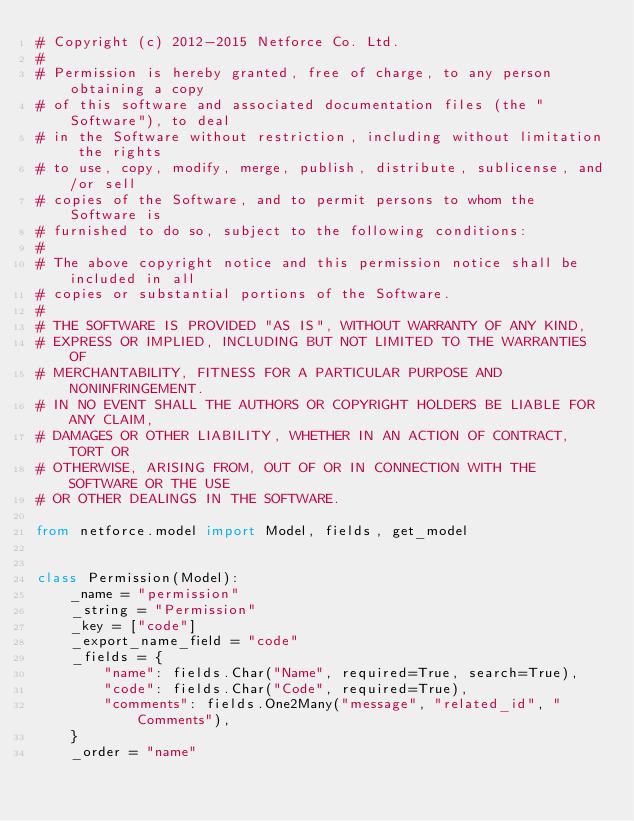Convert code to text. <code><loc_0><loc_0><loc_500><loc_500><_Python_># Copyright (c) 2012-2015 Netforce Co. Ltd.
# 
# Permission is hereby granted, free of charge, to any person obtaining a copy
# of this software and associated documentation files (the "Software"), to deal
# in the Software without restriction, including without limitation the rights
# to use, copy, modify, merge, publish, distribute, sublicense, and/or sell
# copies of the Software, and to permit persons to whom the Software is
# furnished to do so, subject to the following conditions:
# 
# The above copyright notice and this permission notice shall be included in all
# copies or substantial portions of the Software.
# 
# THE SOFTWARE IS PROVIDED "AS IS", WITHOUT WARRANTY OF ANY KIND,
# EXPRESS OR IMPLIED, INCLUDING BUT NOT LIMITED TO THE WARRANTIES OF
# MERCHANTABILITY, FITNESS FOR A PARTICULAR PURPOSE AND NONINFRINGEMENT.
# IN NO EVENT SHALL THE AUTHORS OR COPYRIGHT HOLDERS BE LIABLE FOR ANY CLAIM,
# DAMAGES OR OTHER LIABILITY, WHETHER IN AN ACTION OF CONTRACT, TORT OR
# OTHERWISE, ARISING FROM, OUT OF OR IN CONNECTION WITH THE SOFTWARE OR THE USE
# OR OTHER DEALINGS IN THE SOFTWARE.

from netforce.model import Model, fields, get_model


class Permission(Model):
    _name = "permission"
    _string = "Permission"
    _key = ["code"]
    _export_name_field = "code"
    _fields = {
        "name": fields.Char("Name", required=True, search=True),
        "code": fields.Char("Code", required=True),
        "comments": fields.One2Many("message", "related_id", "Comments"),
    }
    _order = "name"
</code> 